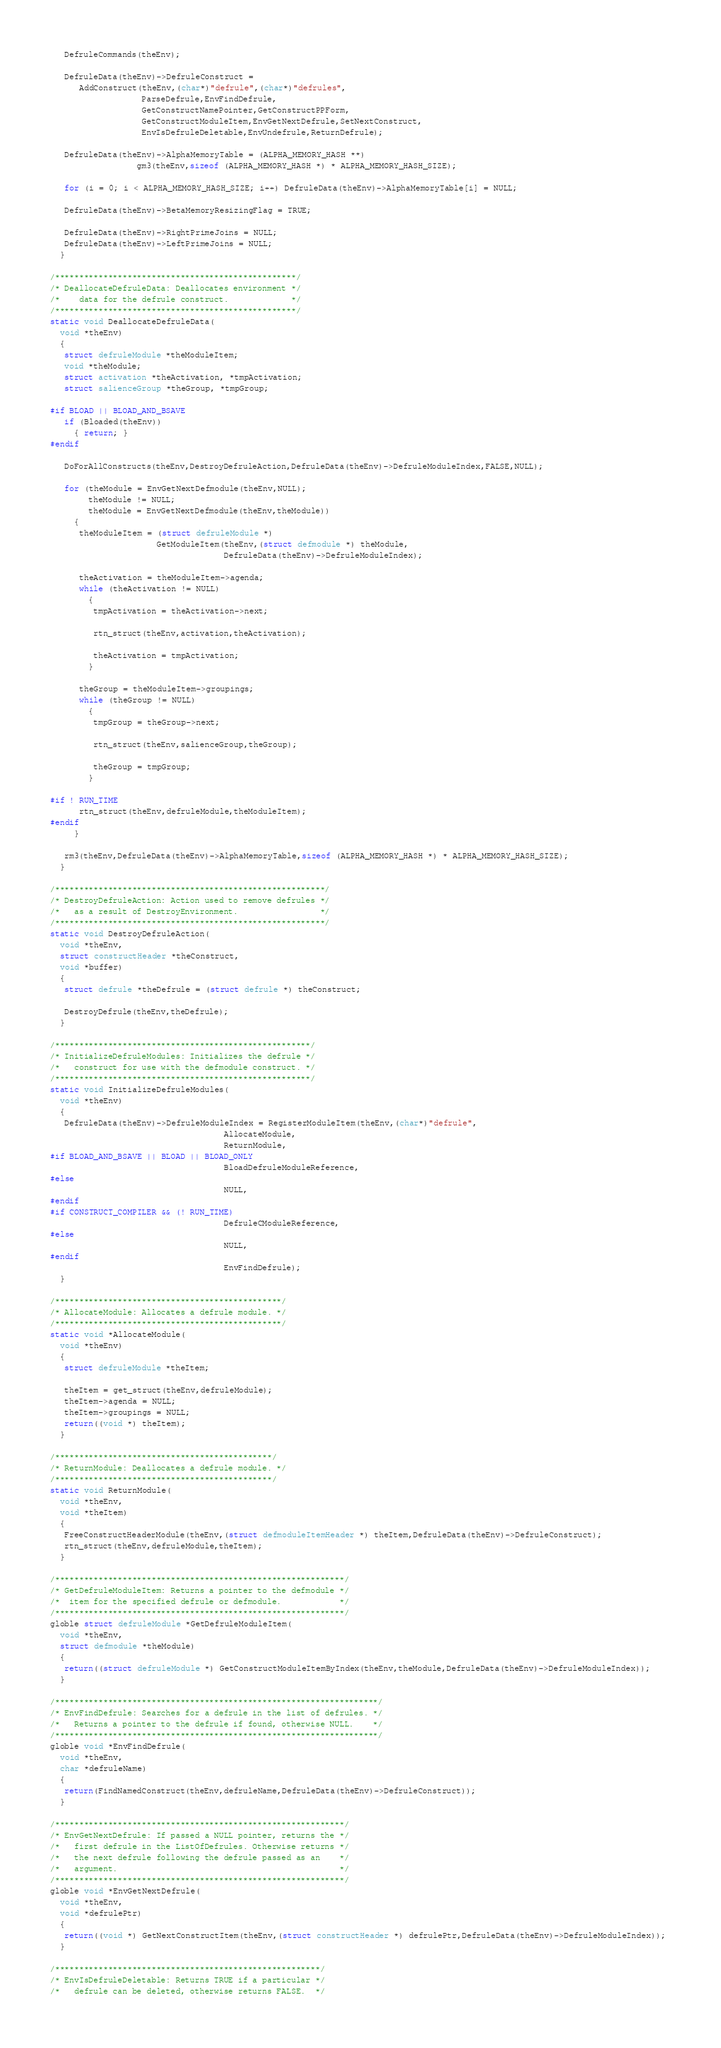<code> <loc_0><loc_0><loc_500><loc_500><_C_>   DefruleCommands(theEnv);

   DefruleData(theEnv)->DefruleConstruct =
      AddConstruct(theEnv,(char*)"defrule",(char*)"defrules",
                   ParseDefrule,EnvFindDefrule,
                   GetConstructNamePointer,GetConstructPPForm,
                   GetConstructModuleItem,EnvGetNextDefrule,SetNextConstruct,
                   EnvIsDefruleDeletable,EnvUndefrule,ReturnDefrule);

   DefruleData(theEnv)->AlphaMemoryTable = (ALPHA_MEMORY_HASH **)
                  gm3(theEnv,sizeof (ALPHA_MEMORY_HASH *) * ALPHA_MEMORY_HASH_SIZE);

   for (i = 0; i < ALPHA_MEMORY_HASH_SIZE; i++) DefruleData(theEnv)->AlphaMemoryTable[i] = NULL;

   DefruleData(theEnv)->BetaMemoryResizingFlag = TRUE;
   
   DefruleData(theEnv)->RightPrimeJoins = NULL;
   DefruleData(theEnv)->LeftPrimeJoins = NULL;   
  }
  
/**************************************************/
/* DeallocateDefruleData: Deallocates environment */
/*    data for the defrule construct.             */
/**************************************************/
static void DeallocateDefruleData(
  void *theEnv)
  {
   struct defruleModule *theModuleItem;
   void *theModule;
   struct activation *theActivation, *tmpActivation;
   struct salienceGroup *theGroup, *tmpGroup;

#if BLOAD || BLOAD_AND_BSAVE
   if (Bloaded(theEnv))
     { return; }
#endif
   
   DoForAllConstructs(theEnv,DestroyDefruleAction,DefruleData(theEnv)->DefruleModuleIndex,FALSE,NULL);

   for (theModule = EnvGetNextDefmodule(theEnv,NULL);
        theModule != NULL;
        theModule = EnvGetNextDefmodule(theEnv,theModule))
     {
      theModuleItem = (struct defruleModule *)
                      GetModuleItem(theEnv,(struct defmodule *) theModule,
                                    DefruleData(theEnv)->DefruleModuleIndex);
                                    
      theActivation = theModuleItem->agenda;
      while (theActivation != NULL)
        {
         tmpActivation = theActivation->next;
         
         rtn_struct(theEnv,activation,theActivation);
         
         theActivation = tmpActivation;
        }
        
      theGroup = theModuleItem->groupings;
      while (theGroup != NULL)
        {
         tmpGroup = theGroup->next;
         
         rtn_struct(theEnv,salienceGroup,theGroup);
         
         theGroup = tmpGroup;
        }        

#if ! RUN_TIME                                    
      rtn_struct(theEnv,defruleModule,theModuleItem);
#endif
     }   
     
   rm3(theEnv,DefruleData(theEnv)->AlphaMemoryTable,sizeof (ALPHA_MEMORY_HASH *) * ALPHA_MEMORY_HASH_SIZE);
  }
  
/********************************************************/
/* DestroyDefruleAction: Action used to remove defrules */
/*   as a result of DestroyEnvironment.                 */
/********************************************************/
static void DestroyDefruleAction(
  void *theEnv,
  struct constructHeader *theConstruct,
  void *buffer)
  {
   struct defrule *theDefrule = (struct defrule *) theConstruct;
   
   DestroyDefrule(theEnv,theDefrule);
  }

/*****************************************************/
/* InitializeDefruleModules: Initializes the defrule */
/*   construct for use with the defmodule construct. */
/*****************************************************/
static void InitializeDefruleModules(
  void *theEnv)
  {
   DefruleData(theEnv)->DefruleModuleIndex = RegisterModuleItem(theEnv,(char*)"defrule",
                                    AllocateModule,
                                    ReturnModule,
#if BLOAD_AND_BSAVE || BLOAD || BLOAD_ONLY
                                    BloadDefruleModuleReference,
#else
                                    NULL,
#endif
#if CONSTRUCT_COMPILER && (! RUN_TIME)
                                    DefruleCModuleReference,
#else
                                    NULL,
#endif
                                    EnvFindDefrule);
  }

/***********************************************/
/* AllocateModule: Allocates a defrule module. */
/***********************************************/
static void *AllocateModule(
  void *theEnv)
  {
   struct defruleModule *theItem;

   theItem = get_struct(theEnv,defruleModule);
   theItem->agenda = NULL;
   theItem->groupings = NULL;
   return((void *) theItem);
  }

/*********************************************/
/* ReturnModule: Deallocates a defrule module. */
/*********************************************/
static void ReturnModule(
  void *theEnv,
  void *theItem)
  {
   FreeConstructHeaderModule(theEnv,(struct defmoduleItemHeader *) theItem,DefruleData(theEnv)->DefruleConstruct);
   rtn_struct(theEnv,defruleModule,theItem);
  }

/************************************************************/
/* GetDefruleModuleItem: Returns a pointer to the defmodule */
/*  item for the specified defrule or defmodule.            */
/************************************************************/
globle struct defruleModule *GetDefruleModuleItem(
  void *theEnv,
  struct defmodule *theModule)
  {   
   return((struct defruleModule *) GetConstructModuleItemByIndex(theEnv,theModule,DefruleData(theEnv)->DefruleModuleIndex)); 
  }

/*******************************************************************/
/* EnvFindDefrule: Searches for a defrule in the list of defrules. */
/*   Returns a pointer to the defrule if found, otherwise NULL.    */
/*******************************************************************/
globle void *EnvFindDefrule(
  void *theEnv,
  char *defruleName)
  {   
   return(FindNamedConstruct(theEnv,defruleName,DefruleData(theEnv)->DefruleConstruct)); 
  }

/************************************************************/
/* EnvGetNextDefrule: If passed a NULL pointer, returns the */
/*   first defrule in the ListOfDefrules. Otherwise returns */
/*   the next defrule following the defrule passed as an    */
/*   argument.                                              */
/************************************************************/
globle void *EnvGetNextDefrule(
  void *theEnv,
  void *defrulePtr)
  {   
   return((void *) GetNextConstructItem(theEnv,(struct constructHeader *) defrulePtr,DefruleData(theEnv)->DefruleModuleIndex)); 
  }

/*******************************************************/
/* EnvIsDefruleDeletable: Returns TRUE if a particular */
/*   defrule can be deleted, otherwise returns FALSE.  */</code> 